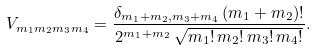<formula> <loc_0><loc_0><loc_500><loc_500>V _ { m _ { 1 } m _ { 2 } m _ { 3 } m _ { 4 } } = \frac { \delta _ { m _ { 1 } + m _ { 2 } , m _ { 3 } + m _ { 4 } } \, ( m _ { 1 } + m _ { 2 } ) ! } { 2 ^ { m _ { 1 } + m _ { 2 } } \, \sqrt { m _ { 1 } ! \, m _ { 2 } ! \, m _ { 3 } ! \, m _ { 4 } ! } } .</formula> 